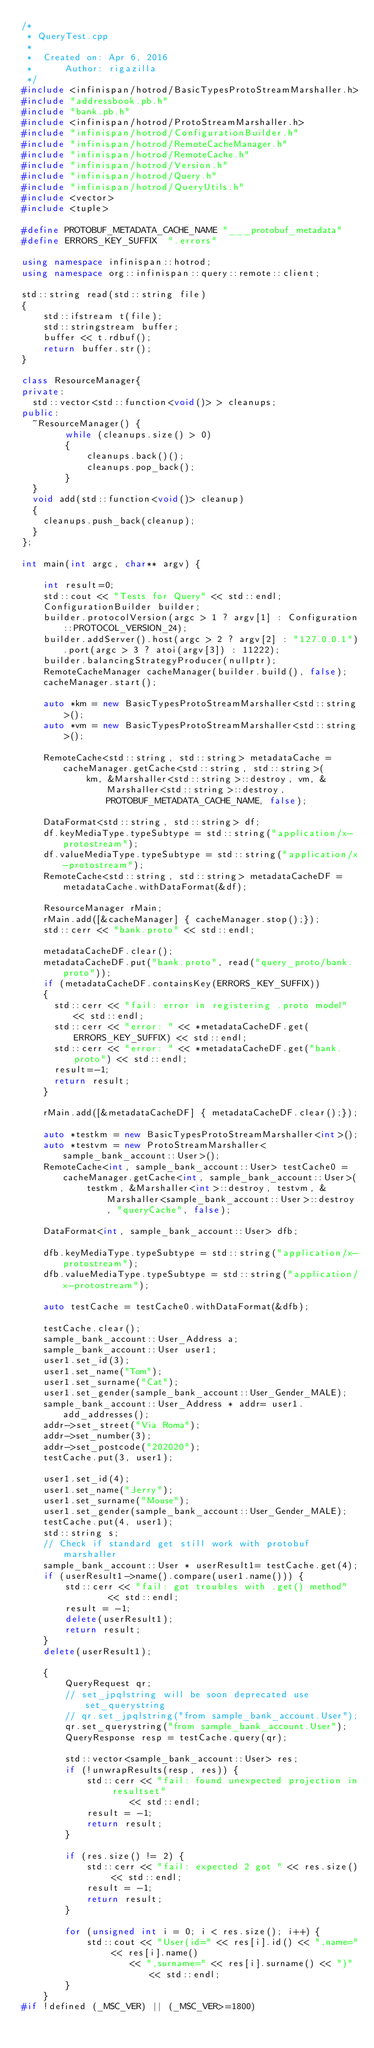<code> <loc_0><loc_0><loc_500><loc_500><_C++_>/*
 * QueryTest.cpp
 *
 *  Created on: Apr 6, 2016
 *      Author: rigazilla
 */
#include <infinispan/hotrod/BasicTypesProtoStreamMarshaller.h>
#include "addressbook.pb.h"
#include "bank.pb.h"
#include <infinispan/hotrod/ProtoStreamMarshaller.h>
#include "infinispan/hotrod/ConfigurationBuilder.h"
#include "infinispan/hotrod/RemoteCacheManager.h"
#include "infinispan/hotrod/RemoteCache.h"
#include "infinispan/hotrod/Version.h"
#include "infinispan/hotrod/Query.h"
#include "infinispan/hotrod/QueryUtils.h"
#include <vector>
#include <tuple>

#define PROTOBUF_METADATA_CACHE_NAME "___protobuf_metadata"
#define ERRORS_KEY_SUFFIX  ".errors"

using namespace infinispan::hotrod;
using namespace org::infinispan::query::remote::client;

std::string read(std::string file)
{
    std::ifstream t(file);
    std::stringstream buffer;
    buffer << t.rdbuf();
    return buffer.str();
}

class ResourceManager{
private:
	std::vector<std::function<void()> > cleanups;
public:
	~ResourceManager() {
        while (cleanups.size() > 0)
        {
            cleanups.back()();
            cleanups.pop_back();
        }
	}
	void add(std::function<void()> cleanup)
	{
		cleanups.push_back(cleanup);
	}
};

int main(int argc, char** argv) {

    int result=0;
    std::cout << "Tests for Query" << std::endl;
    ConfigurationBuilder builder;
    builder.protocolVersion(argc > 1 ? argv[1] : Configuration::PROTOCOL_VERSION_24);
    builder.addServer().host(argc > 2 ? argv[2] : "127.0.0.1").port(argc > 3 ? atoi(argv[3]) : 11222);
    builder.balancingStrategyProducer(nullptr);
    RemoteCacheManager cacheManager(builder.build(), false);
    cacheManager.start();

    auto *km = new BasicTypesProtoStreamMarshaller<std::string>();
    auto *vm = new BasicTypesProtoStreamMarshaller<std::string>();

    RemoteCache<std::string, std::string> metadataCache = cacheManager.getCache<std::string, std::string>(
            km, &Marshaller<std::string>::destroy, vm, &Marshaller<std::string>::destroy,PROTOBUF_METADATA_CACHE_NAME, false);

    DataFormat<std::string, std::string> df;
    df.keyMediaType.typeSubtype = std::string("application/x-protostream");
    df.valueMediaType.typeSubtype = std::string("application/x-protostream");
    RemoteCache<std::string, std::string> metadataCacheDF = metadataCache.withDataFormat(&df);

    ResourceManager rMain;
    rMain.add([&cacheManager] { cacheManager.stop();});
    std::cerr << "bank.proto" << std::endl;

    metadataCacheDF.clear();
    metadataCacheDF.put("bank.proto", read("query_proto/bank.proto"));
    if (metadataCacheDF.containsKey(ERRORS_KEY_SUFFIX))
    {
      std::cerr << "fail: error in registering .proto model" << std::endl;
      std::cerr << "error: " << *metadataCacheDF.get(ERRORS_KEY_SUFFIX) << std::endl;
      std::cerr << "error: " << *metadataCacheDF.get("bank.proto") << std::endl;
      result=-1;
      return result;
    }

    rMain.add([&metadataCacheDF] { metadataCacheDF.clear();});

    auto *testkm = new BasicTypesProtoStreamMarshaller<int>();
    auto *testvm = new ProtoStreamMarshaller<sample_bank_account::User>();
    RemoteCache<int, sample_bank_account::User> testCache0 = cacheManager.getCache<int, sample_bank_account::User>(
            testkm, &Marshaller<int>::destroy, testvm, &Marshaller<sample_bank_account::User>::destroy, "queryCache", false);

    DataFormat<int, sample_bank_account::User> dfb;

    dfb.keyMediaType.typeSubtype = std::string("application/x-protostream");
    dfb.valueMediaType.typeSubtype = std::string("application/x-protostream");

    auto testCache = testCache0.withDataFormat(&dfb);

    testCache.clear();
    sample_bank_account::User_Address a;
    sample_bank_account::User user1;
    user1.set_id(3);
    user1.set_name("Tom");
    user1.set_surname("Cat");
    user1.set_gender(sample_bank_account::User_Gender_MALE);
    sample_bank_account::User_Address * addr= user1.add_addresses();
    addr->set_street("Via Roma");
    addr->set_number(3);
    addr->set_postcode("202020");
    testCache.put(3, user1);

    user1.set_id(4);
    user1.set_name("Jerry");
    user1.set_surname("Mouse");
    user1.set_gender(sample_bank_account::User_Gender_MALE);
    testCache.put(4, user1);
    std::string s;
    // Check if standard get still work with protobuf marshaller
    sample_bank_account::User * userResult1= testCache.get(4);
    if (userResult1->name().compare(user1.name())) {
        std::cerr << "fail: got troubles with .get() method"
                << std::endl;
        result = -1;
        delete(userResult1);
        return result;
    }
    delete(userResult1);

    {
        QueryRequest qr;
        // set_jpqlstring will be soon deprecated use set_querystring
        // qr.set_jpqlstring("from sample_bank_account.User");
        qr.set_querystring("from sample_bank_account.User");
        QueryResponse resp = testCache.query(qr);

        std::vector<sample_bank_account::User> res;
        if (!unwrapResults(resp, res)) {
            std::cerr << "fail: found unexpected projection in resultset"
                    << std::endl;
            result = -1;
            return result;
        }

        if (res.size() != 2) {
            std::cerr << "fail: expected 2 got " << res.size() << std::endl;
            result = -1;
            return result;
        }

        for (unsigned int i = 0; i < res.size(); i++) {
            std::cout << "User(id=" << res[i].id() << ",name=" << res[i].name()
                    << ",surname=" << res[i].surname() << ")" << std::endl;
        }
    }
#if !defined (_MSC_VER) || (_MSC_VER>=1800)</code> 